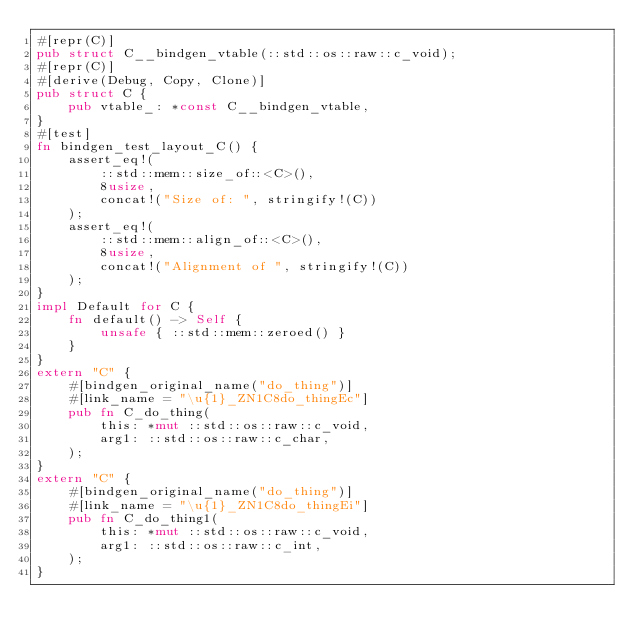<code> <loc_0><loc_0><loc_500><loc_500><_Rust_>#[repr(C)]
pub struct C__bindgen_vtable(::std::os::raw::c_void);
#[repr(C)]
#[derive(Debug, Copy, Clone)]
pub struct C {
    pub vtable_: *const C__bindgen_vtable,
}
#[test]
fn bindgen_test_layout_C() {
    assert_eq!(
        ::std::mem::size_of::<C>(),
        8usize,
        concat!("Size of: ", stringify!(C))
    );
    assert_eq!(
        ::std::mem::align_of::<C>(),
        8usize,
        concat!("Alignment of ", stringify!(C))
    );
}
impl Default for C {
    fn default() -> Self {
        unsafe { ::std::mem::zeroed() }
    }
}
extern "C" {
    #[bindgen_original_name("do_thing")]
    #[link_name = "\u{1}_ZN1C8do_thingEc"]
    pub fn C_do_thing(
        this: *mut ::std::os::raw::c_void,
        arg1: ::std::os::raw::c_char,
    );
}
extern "C" {
    #[bindgen_original_name("do_thing")]
    #[link_name = "\u{1}_ZN1C8do_thingEi"]
    pub fn C_do_thing1(
        this: *mut ::std::os::raw::c_void,
        arg1: ::std::os::raw::c_int,
    );
}
</code> 